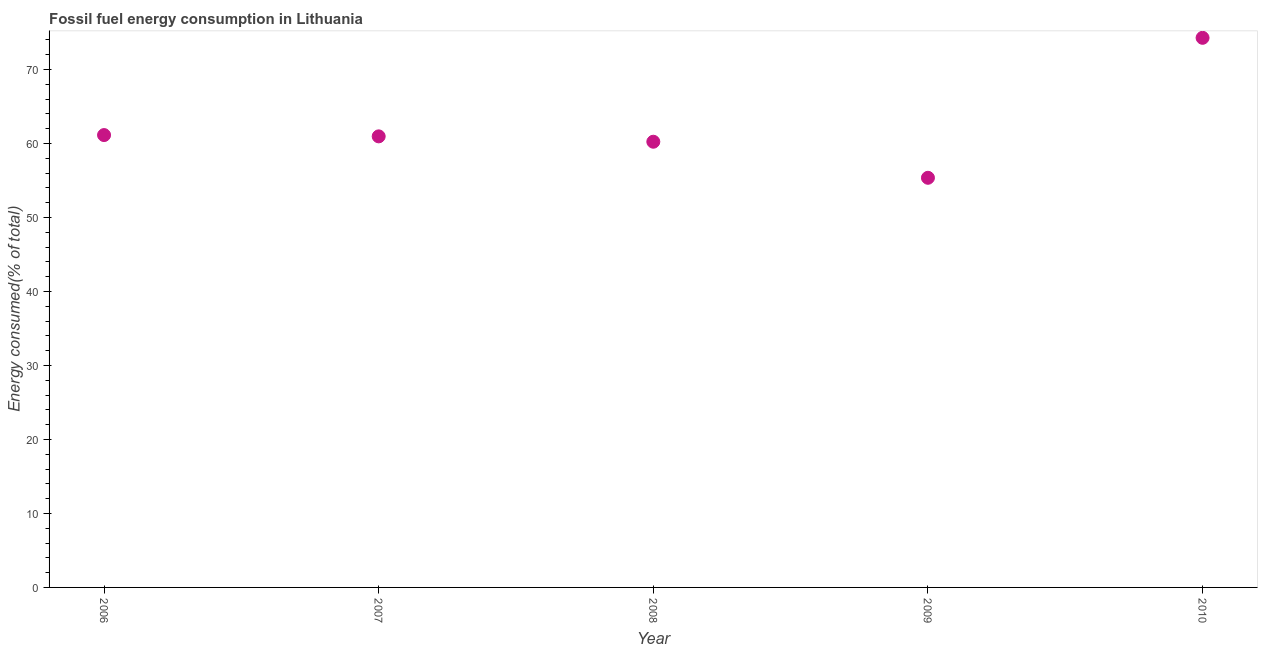What is the fossil fuel energy consumption in 2010?
Provide a succinct answer. 74.29. Across all years, what is the maximum fossil fuel energy consumption?
Provide a succinct answer. 74.29. Across all years, what is the minimum fossil fuel energy consumption?
Offer a terse response. 55.37. What is the sum of the fossil fuel energy consumption?
Offer a very short reply. 312.02. What is the difference between the fossil fuel energy consumption in 2007 and 2010?
Offer a very short reply. -13.32. What is the average fossil fuel energy consumption per year?
Provide a short and direct response. 62.4. What is the median fossil fuel energy consumption?
Your response must be concise. 60.97. In how many years, is the fossil fuel energy consumption greater than 8 %?
Your response must be concise. 5. What is the ratio of the fossil fuel energy consumption in 2006 to that in 2010?
Your response must be concise. 0.82. Is the fossil fuel energy consumption in 2006 less than that in 2007?
Your answer should be very brief. No. What is the difference between the highest and the second highest fossil fuel energy consumption?
Offer a terse response. 13.14. Is the sum of the fossil fuel energy consumption in 2008 and 2010 greater than the maximum fossil fuel energy consumption across all years?
Provide a succinct answer. Yes. What is the difference between the highest and the lowest fossil fuel energy consumption?
Offer a very short reply. 18.92. In how many years, is the fossil fuel energy consumption greater than the average fossil fuel energy consumption taken over all years?
Provide a succinct answer. 1. How many years are there in the graph?
Your response must be concise. 5. Are the values on the major ticks of Y-axis written in scientific E-notation?
Provide a short and direct response. No. Does the graph contain any zero values?
Ensure brevity in your answer.  No. What is the title of the graph?
Your answer should be compact. Fossil fuel energy consumption in Lithuania. What is the label or title of the X-axis?
Offer a very short reply. Year. What is the label or title of the Y-axis?
Your response must be concise. Energy consumed(% of total). What is the Energy consumed(% of total) in 2006?
Give a very brief answer. 61.15. What is the Energy consumed(% of total) in 2007?
Ensure brevity in your answer.  60.97. What is the Energy consumed(% of total) in 2008?
Keep it short and to the point. 60.25. What is the Energy consumed(% of total) in 2009?
Offer a terse response. 55.37. What is the Energy consumed(% of total) in 2010?
Ensure brevity in your answer.  74.29. What is the difference between the Energy consumed(% of total) in 2006 and 2007?
Make the answer very short. 0.17. What is the difference between the Energy consumed(% of total) in 2006 and 2008?
Make the answer very short. 0.9. What is the difference between the Energy consumed(% of total) in 2006 and 2009?
Provide a short and direct response. 5.77. What is the difference between the Energy consumed(% of total) in 2006 and 2010?
Make the answer very short. -13.14. What is the difference between the Energy consumed(% of total) in 2007 and 2008?
Your response must be concise. 0.73. What is the difference between the Energy consumed(% of total) in 2007 and 2009?
Your answer should be compact. 5.6. What is the difference between the Energy consumed(% of total) in 2007 and 2010?
Make the answer very short. -13.32. What is the difference between the Energy consumed(% of total) in 2008 and 2009?
Your answer should be very brief. 4.87. What is the difference between the Energy consumed(% of total) in 2008 and 2010?
Provide a short and direct response. -14.05. What is the difference between the Energy consumed(% of total) in 2009 and 2010?
Give a very brief answer. -18.92. What is the ratio of the Energy consumed(% of total) in 2006 to that in 2007?
Provide a short and direct response. 1. What is the ratio of the Energy consumed(% of total) in 2006 to that in 2009?
Offer a very short reply. 1.1. What is the ratio of the Energy consumed(% of total) in 2006 to that in 2010?
Your response must be concise. 0.82. What is the ratio of the Energy consumed(% of total) in 2007 to that in 2009?
Make the answer very short. 1.1. What is the ratio of the Energy consumed(% of total) in 2007 to that in 2010?
Your answer should be very brief. 0.82. What is the ratio of the Energy consumed(% of total) in 2008 to that in 2009?
Ensure brevity in your answer.  1.09. What is the ratio of the Energy consumed(% of total) in 2008 to that in 2010?
Your answer should be very brief. 0.81. What is the ratio of the Energy consumed(% of total) in 2009 to that in 2010?
Offer a very short reply. 0.74. 